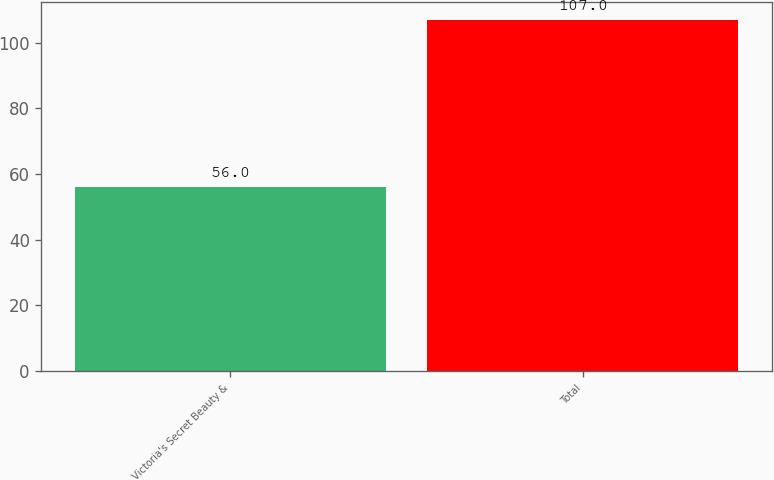Convert chart. <chart><loc_0><loc_0><loc_500><loc_500><bar_chart><fcel>Victoria's Secret Beauty &<fcel>Total<nl><fcel>56<fcel>107<nl></chart> 